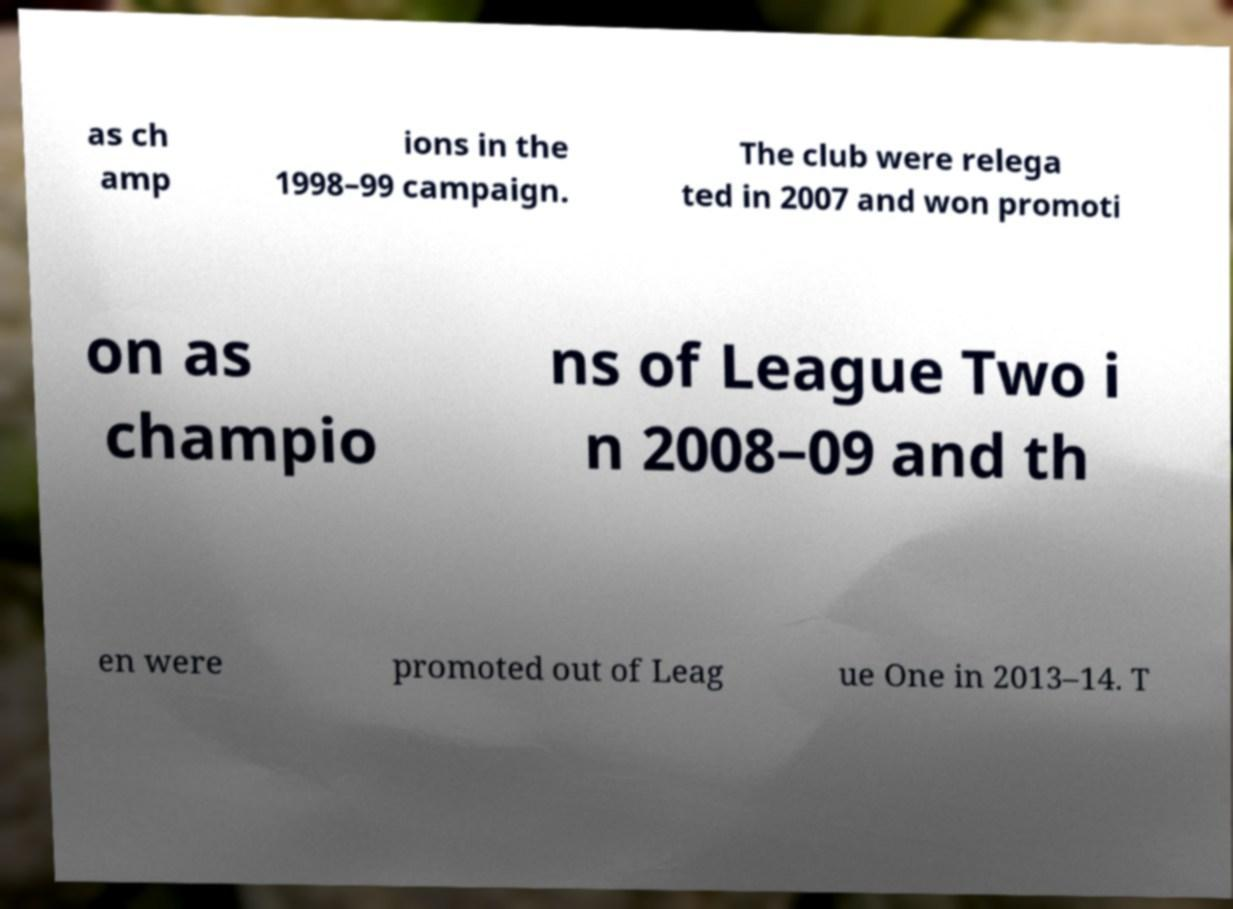Please identify and transcribe the text found in this image. as ch amp ions in the 1998–99 campaign. The club were relega ted in 2007 and won promoti on as champio ns of League Two i n 2008–09 and th en were promoted out of Leag ue One in 2013–14. T 